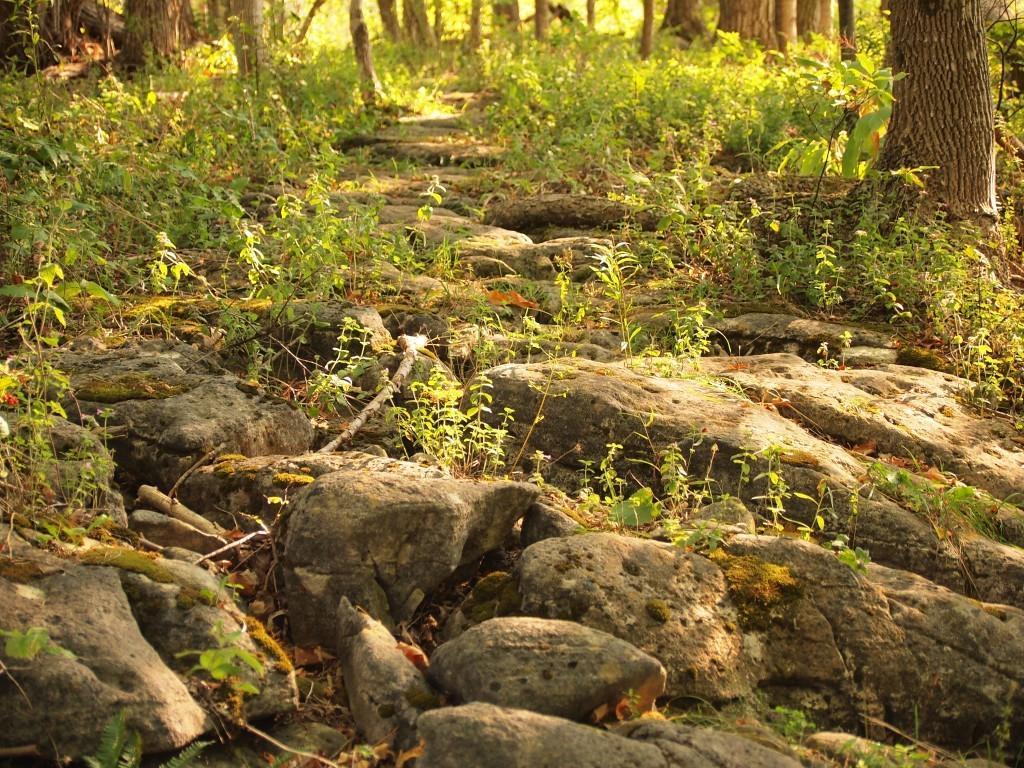Can you describe this image briefly? In the image we can see some stones and grass and trees. 